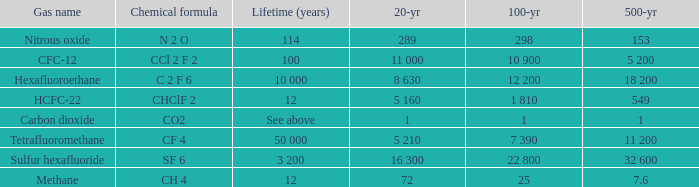Can you parse all the data within this table? {'header': ['Gas name', 'Chemical formula', 'Lifetime (years)', '20-yr', '100-yr', '500-yr'], 'rows': [['Nitrous oxide', 'N 2 O', '114', '289', '298', '153'], ['CFC-12', 'CCl 2 F 2', '100', '11 000', '10 900', '5 200'], ['Hexafluoroethane', 'C 2 F 6', '10 000', '8 630', '12 200', '18 200'], ['HCFC-22', 'CHClF 2', '12', '5 160', '1 810', '549'], ['Carbon dioxide', 'CO2', 'See above', '1', '1', '1'], ['Tetrafluoromethane', 'CF 4', '50 000', '5 210', '7 390', '11 200'], ['Sulfur hexafluoride', 'SF 6', '3 200', '16 300', '22 800', '32 600'], ['Methane', 'CH 4', '12', '72', '25', '7.6']]} What is the 20 year for Nitrous Oxide? 289.0. 